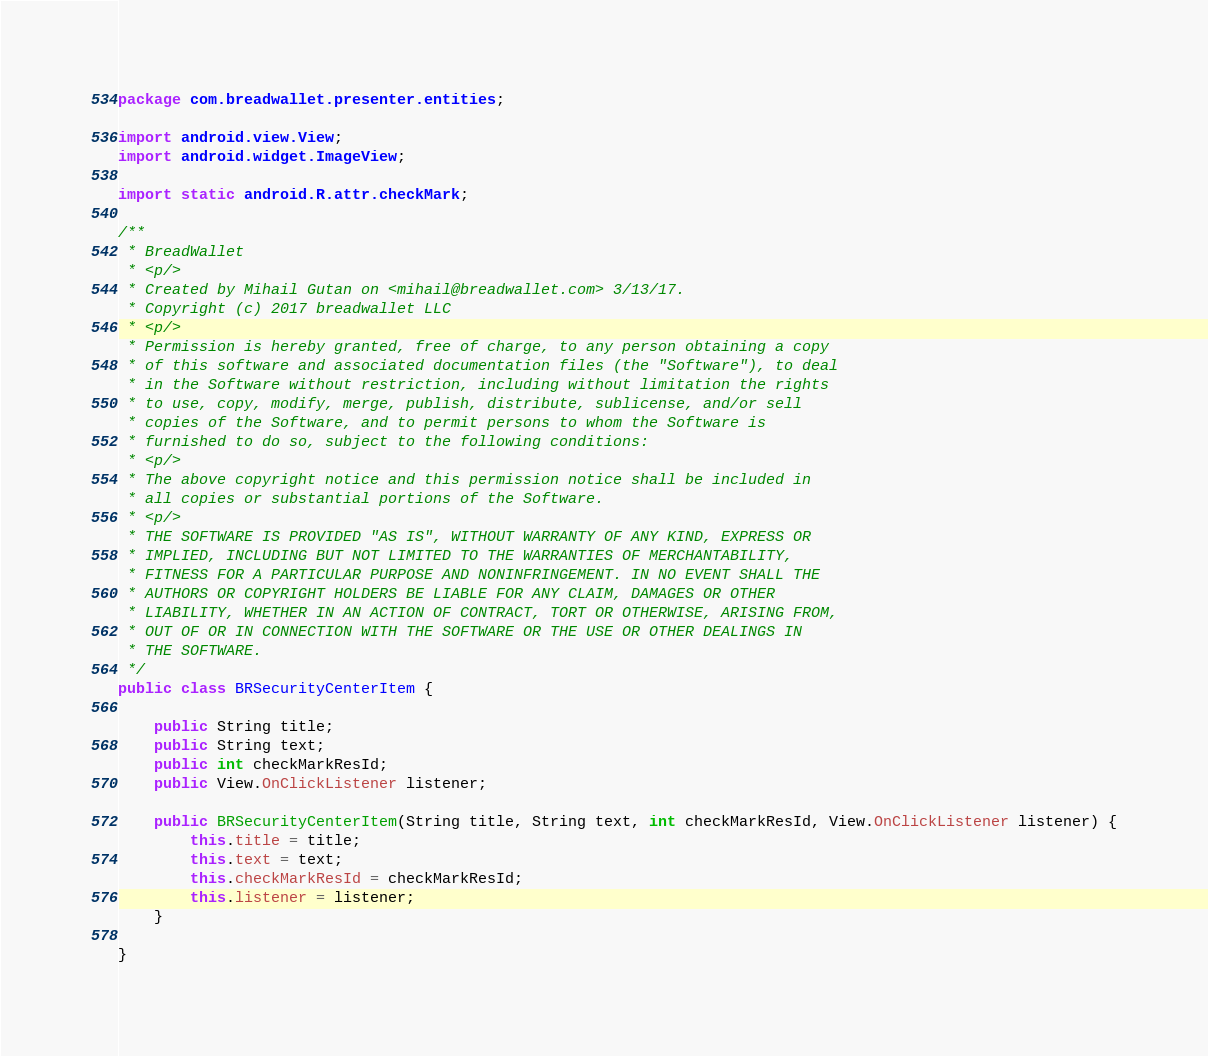<code> <loc_0><loc_0><loc_500><loc_500><_Java_>package com.breadwallet.presenter.entities;

import android.view.View;
import android.widget.ImageView;

import static android.R.attr.checkMark;

/**
 * BreadWallet
 * <p/>
 * Created by Mihail Gutan on <mihail@breadwallet.com> 3/13/17.
 * Copyright (c) 2017 breadwallet LLC
 * <p/>
 * Permission is hereby granted, free of charge, to any person obtaining a copy
 * of this software and associated documentation files (the "Software"), to deal
 * in the Software without restriction, including without limitation the rights
 * to use, copy, modify, merge, publish, distribute, sublicense, and/or sell
 * copies of the Software, and to permit persons to whom the Software is
 * furnished to do so, subject to the following conditions:
 * <p/>
 * The above copyright notice and this permission notice shall be included in
 * all copies or substantial portions of the Software.
 * <p/>
 * THE SOFTWARE IS PROVIDED "AS IS", WITHOUT WARRANTY OF ANY KIND, EXPRESS OR
 * IMPLIED, INCLUDING BUT NOT LIMITED TO THE WARRANTIES OF MERCHANTABILITY,
 * FITNESS FOR A PARTICULAR PURPOSE AND NONINFRINGEMENT. IN NO EVENT SHALL THE
 * AUTHORS OR COPYRIGHT HOLDERS BE LIABLE FOR ANY CLAIM, DAMAGES OR OTHER
 * LIABILITY, WHETHER IN AN ACTION OF CONTRACT, TORT OR OTHERWISE, ARISING FROM,
 * OUT OF OR IN CONNECTION WITH THE SOFTWARE OR THE USE OR OTHER DEALINGS IN
 * THE SOFTWARE.
 */
public class BRSecurityCenterItem {

    public String title;
    public String text;
    public int checkMarkResId;
    public View.OnClickListener listener;

    public BRSecurityCenterItem(String title, String text, int checkMarkResId, View.OnClickListener listener) {
        this.title = title;
        this.text = text;
        this.checkMarkResId = checkMarkResId;
        this.listener = listener;
    }

}</code> 